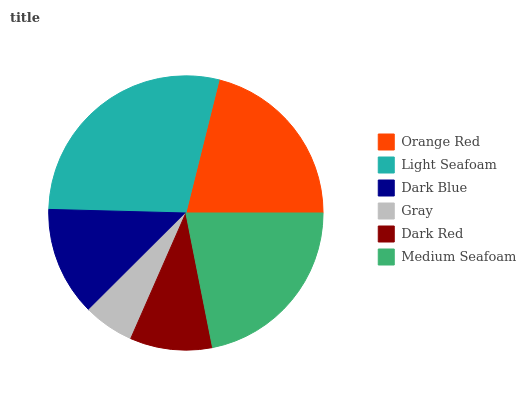Is Gray the minimum?
Answer yes or no. Yes. Is Light Seafoam the maximum?
Answer yes or no. Yes. Is Dark Blue the minimum?
Answer yes or no. No. Is Dark Blue the maximum?
Answer yes or no. No. Is Light Seafoam greater than Dark Blue?
Answer yes or no. Yes. Is Dark Blue less than Light Seafoam?
Answer yes or no. Yes. Is Dark Blue greater than Light Seafoam?
Answer yes or no. No. Is Light Seafoam less than Dark Blue?
Answer yes or no. No. Is Orange Red the high median?
Answer yes or no. Yes. Is Dark Blue the low median?
Answer yes or no. Yes. Is Medium Seafoam the high median?
Answer yes or no. No. Is Gray the low median?
Answer yes or no. No. 